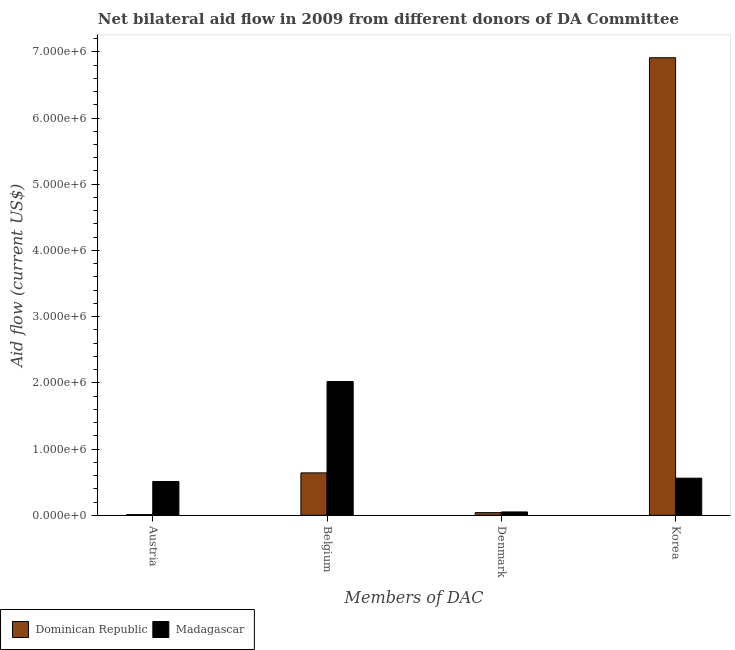How many bars are there on the 2nd tick from the left?
Give a very brief answer. 2. What is the label of the 4th group of bars from the left?
Give a very brief answer. Korea. What is the amount of aid given by austria in Madagascar?
Your response must be concise. 5.10e+05. Across all countries, what is the maximum amount of aid given by austria?
Provide a short and direct response. 5.10e+05. Across all countries, what is the minimum amount of aid given by denmark?
Provide a succinct answer. 4.00e+04. In which country was the amount of aid given by belgium maximum?
Offer a very short reply. Madagascar. In which country was the amount of aid given by belgium minimum?
Provide a succinct answer. Dominican Republic. What is the total amount of aid given by korea in the graph?
Make the answer very short. 7.47e+06. What is the difference between the amount of aid given by austria in Madagascar and that in Dominican Republic?
Your answer should be compact. 5.00e+05. What is the difference between the amount of aid given by austria in Madagascar and the amount of aid given by korea in Dominican Republic?
Make the answer very short. -6.40e+06. What is the average amount of aid given by belgium per country?
Provide a short and direct response. 1.33e+06. What is the difference between the amount of aid given by belgium and amount of aid given by austria in Madagascar?
Your answer should be very brief. 1.51e+06. In how many countries, is the amount of aid given by korea greater than 6200000 US$?
Make the answer very short. 1. Is the difference between the amount of aid given by belgium in Madagascar and Dominican Republic greater than the difference between the amount of aid given by korea in Madagascar and Dominican Republic?
Provide a succinct answer. Yes. What is the difference between the highest and the second highest amount of aid given by denmark?
Give a very brief answer. 10000. What is the difference between the highest and the lowest amount of aid given by belgium?
Provide a succinct answer. 1.38e+06. In how many countries, is the amount of aid given by korea greater than the average amount of aid given by korea taken over all countries?
Keep it short and to the point. 1. Is the sum of the amount of aid given by austria in Madagascar and Dominican Republic greater than the maximum amount of aid given by korea across all countries?
Give a very brief answer. No. What does the 1st bar from the left in Denmark represents?
Make the answer very short. Dominican Republic. What does the 1st bar from the right in Austria represents?
Provide a short and direct response. Madagascar. How many bars are there?
Make the answer very short. 8. Are all the bars in the graph horizontal?
Ensure brevity in your answer.  No. How many countries are there in the graph?
Ensure brevity in your answer.  2. What is the difference between two consecutive major ticks on the Y-axis?
Make the answer very short. 1.00e+06. Are the values on the major ticks of Y-axis written in scientific E-notation?
Keep it short and to the point. Yes. Does the graph contain any zero values?
Provide a succinct answer. No. Does the graph contain grids?
Ensure brevity in your answer.  No. Where does the legend appear in the graph?
Ensure brevity in your answer.  Bottom left. How many legend labels are there?
Your answer should be compact. 2. How are the legend labels stacked?
Provide a short and direct response. Horizontal. What is the title of the graph?
Offer a very short reply. Net bilateral aid flow in 2009 from different donors of DA Committee. What is the label or title of the X-axis?
Provide a short and direct response. Members of DAC. What is the Aid flow (current US$) of Dominican Republic in Austria?
Your response must be concise. 10000. What is the Aid flow (current US$) in Madagascar in Austria?
Your answer should be compact. 5.10e+05. What is the Aid flow (current US$) of Dominican Republic in Belgium?
Offer a terse response. 6.40e+05. What is the Aid flow (current US$) of Madagascar in Belgium?
Make the answer very short. 2.02e+06. What is the Aid flow (current US$) in Madagascar in Denmark?
Your answer should be very brief. 5.00e+04. What is the Aid flow (current US$) in Dominican Republic in Korea?
Your answer should be compact. 6.91e+06. What is the Aid flow (current US$) of Madagascar in Korea?
Your answer should be very brief. 5.60e+05. Across all Members of DAC, what is the maximum Aid flow (current US$) in Dominican Republic?
Provide a succinct answer. 6.91e+06. Across all Members of DAC, what is the maximum Aid flow (current US$) of Madagascar?
Keep it short and to the point. 2.02e+06. Across all Members of DAC, what is the minimum Aid flow (current US$) in Madagascar?
Your response must be concise. 5.00e+04. What is the total Aid flow (current US$) of Dominican Republic in the graph?
Provide a succinct answer. 7.60e+06. What is the total Aid flow (current US$) of Madagascar in the graph?
Offer a very short reply. 3.14e+06. What is the difference between the Aid flow (current US$) of Dominican Republic in Austria and that in Belgium?
Your answer should be compact. -6.30e+05. What is the difference between the Aid flow (current US$) of Madagascar in Austria and that in Belgium?
Provide a succinct answer. -1.51e+06. What is the difference between the Aid flow (current US$) in Dominican Republic in Austria and that in Denmark?
Provide a succinct answer. -3.00e+04. What is the difference between the Aid flow (current US$) in Dominican Republic in Austria and that in Korea?
Keep it short and to the point. -6.90e+06. What is the difference between the Aid flow (current US$) in Dominican Republic in Belgium and that in Denmark?
Your answer should be very brief. 6.00e+05. What is the difference between the Aid flow (current US$) of Madagascar in Belgium and that in Denmark?
Your response must be concise. 1.97e+06. What is the difference between the Aid flow (current US$) of Dominican Republic in Belgium and that in Korea?
Ensure brevity in your answer.  -6.27e+06. What is the difference between the Aid flow (current US$) in Madagascar in Belgium and that in Korea?
Your response must be concise. 1.46e+06. What is the difference between the Aid flow (current US$) in Dominican Republic in Denmark and that in Korea?
Ensure brevity in your answer.  -6.87e+06. What is the difference between the Aid flow (current US$) in Madagascar in Denmark and that in Korea?
Give a very brief answer. -5.10e+05. What is the difference between the Aid flow (current US$) of Dominican Republic in Austria and the Aid flow (current US$) of Madagascar in Belgium?
Give a very brief answer. -2.01e+06. What is the difference between the Aid flow (current US$) of Dominican Republic in Austria and the Aid flow (current US$) of Madagascar in Korea?
Your response must be concise. -5.50e+05. What is the difference between the Aid flow (current US$) of Dominican Republic in Belgium and the Aid flow (current US$) of Madagascar in Denmark?
Provide a short and direct response. 5.90e+05. What is the difference between the Aid flow (current US$) in Dominican Republic in Denmark and the Aid flow (current US$) in Madagascar in Korea?
Offer a terse response. -5.20e+05. What is the average Aid flow (current US$) in Dominican Republic per Members of DAC?
Provide a short and direct response. 1.90e+06. What is the average Aid flow (current US$) in Madagascar per Members of DAC?
Provide a succinct answer. 7.85e+05. What is the difference between the Aid flow (current US$) in Dominican Republic and Aid flow (current US$) in Madagascar in Austria?
Ensure brevity in your answer.  -5.00e+05. What is the difference between the Aid flow (current US$) of Dominican Republic and Aid flow (current US$) of Madagascar in Belgium?
Provide a short and direct response. -1.38e+06. What is the difference between the Aid flow (current US$) of Dominican Republic and Aid flow (current US$) of Madagascar in Denmark?
Your answer should be very brief. -10000. What is the difference between the Aid flow (current US$) of Dominican Republic and Aid flow (current US$) of Madagascar in Korea?
Provide a short and direct response. 6.35e+06. What is the ratio of the Aid flow (current US$) in Dominican Republic in Austria to that in Belgium?
Your answer should be compact. 0.02. What is the ratio of the Aid flow (current US$) in Madagascar in Austria to that in Belgium?
Provide a succinct answer. 0.25. What is the ratio of the Aid flow (current US$) of Dominican Republic in Austria to that in Denmark?
Your answer should be compact. 0.25. What is the ratio of the Aid flow (current US$) of Dominican Republic in Austria to that in Korea?
Make the answer very short. 0. What is the ratio of the Aid flow (current US$) of Madagascar in Austria to that in Korea?
Offer a very short reply. 0.91. What is the ratio of the Aid flow (current US$) of Madagascar in Belgium to that in Denmark?
Provide a succinct answer. 40.4. What is the ratio of the Aid flow (current US$) in Dominican Republic in Belgium to that in Korea?
Your answer should be very brief. 0.09. What is the ratio of the Aid flow (current US$) of Madagascar in Belgium to that in Korea?
Your answer should be very brief. 3.61. What is the ratio of the Aid flow (current US$) of Dominican Republic in Denmark to that in Korea?
Your response must be concise. 0.01. What is the ratio of the Aid flow (current US$) of Madagascar in Denmark to that in Korea?
Offer a very short reply. 0.09. What is the difference between the highest and the second highest Aid flow (current US$) in Dominican Republic?
Provide a short and direct response. 6.27e+06. What is the difference between the highest and the second highest Aid flow (current US$) of Madagascar?
Offer a very short reply. 1.46e+06. What is the difference between the highest and the lowest Aid flow (current US$) in Dominican Republic?
Offer a terse response. 6.90e+06. What is the difference between the highest and the lowest Aid flow (current US$) in Madagascar?
Provide a short and direct response. 1.97e+06. 